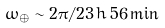<formula> <loc_0><loc_0><loc_500><loc_500>\omega _ { \oplus } \sim 2 \pi / 2 3 \, { h } \, 5 6 \, { \min }</formula> 